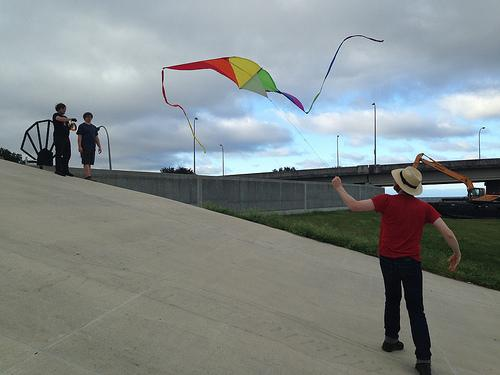Identify the colors of the kite in the image. The kite is colorful, featuring red, yellow, and green colors. Describe the primary activity taking place in the image. A person is flying a rainbow-colored kite in front of a cloudy sky, while others observe from the background. What type of hat is the man wearing, and what color is it? The man is wearing a white cap or a beige straw hat. What is the setting of the image? The setting is an outdoor park or grassy area with a long wooden fence, a construction crane near a bridge, and cloudy sky overhead. What are the main colors of the person's outfit in the foreground? The main outfit colors are red for the shirt and black for the pants. Where is the orange construction crane located in relation to the other objects in the image? The orange construction crane is located under a bridge, close to the man flying the kite. What are the two people in the background wearing? The two people in the background are wearing dark-colored clothing, including black shirts and black pants or shorts. Mention one object present in the sky in the image. There is a multicolored kite flying in the wind in the sky. Provide a brief description of the scene depicted in the image. The picture shows a man wearing a red shirt and white hat, flying a rainbow-colored kite under a cloudy sky, with a long wooden fence, two people standing in the background, and an orange construction crane under a bridge. What is the man in the red shirt holding? The man in the red shirt is holding the string of a colorful kite. 